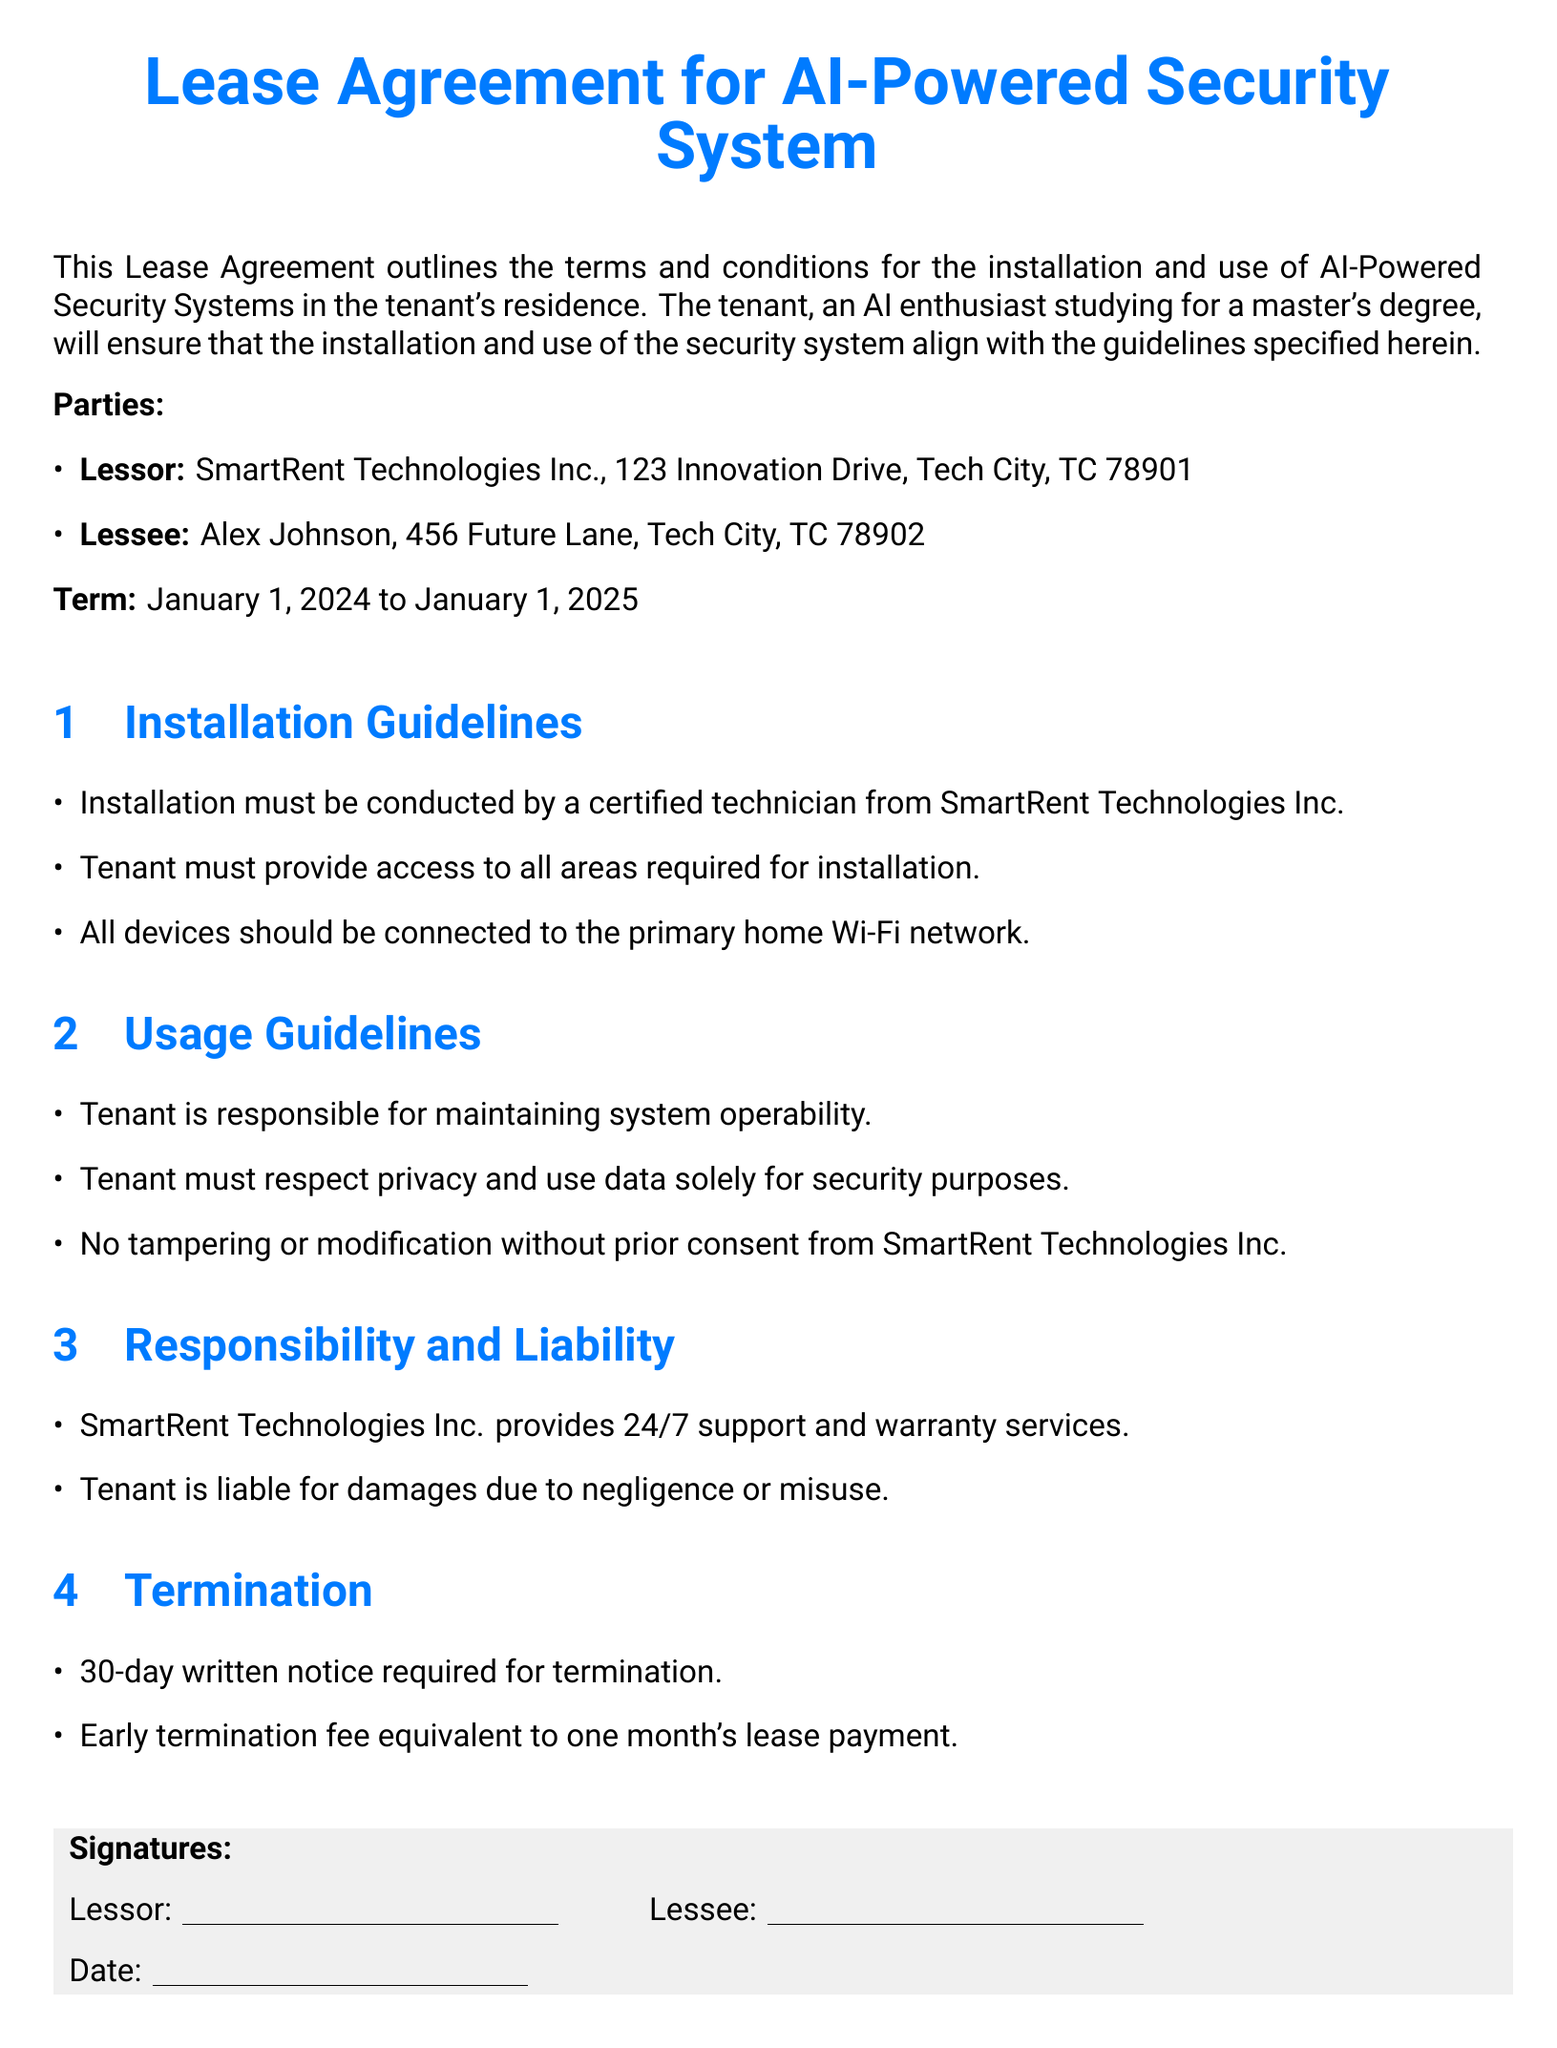What is the name of the lessor? The lessor is named SmartRent Technologies Inc.
Answer: SmartRent Technologies Inc What is the address of the lessee? The lessee resides at 456 Future Lane, Tech City, TC 78902.
Answer: 456 Future Lane, Tech City, TC 78902 What is the rental term start date? The rental term starts on January 1, 2024.
Answer: January 1, 2024 Who must conduct the installation? The installation must be conducted by a certified technician.
Answer: certified technician What is the tenant responsible for regarding the security system? The tenant is responsible for maintaining system operability.
Answer: maintaining system operability How many days' notice is required for termination? A 30-day written notice is required for termination.
Answer: 30-day What is the early termination fee? The early termination fee is equivalent to one month's lease payment.
Answer: one month's lease payment What type of support does SmartRent Technologies Inc. provide? SmartRent Technologies Inc. provides 24/7 support and warranty services.
Answer: 24/7 support Is tampering or modification of the system allowed? No, tampering or modification is not allowed without consent.
Answer: No 